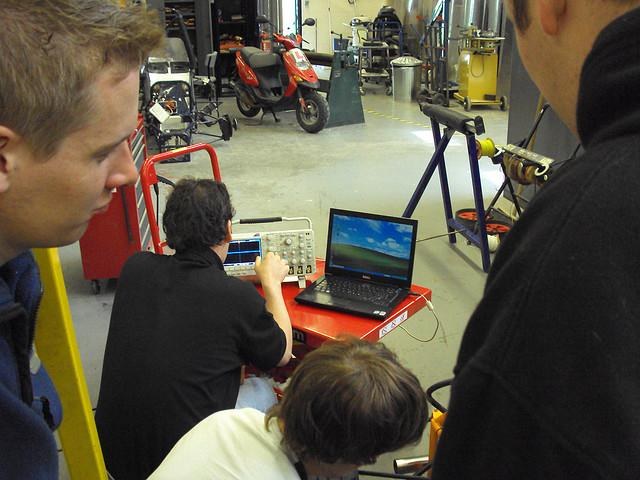What is the man using to control the grey device?

Choices:
A) desktop
B) phone
C) laptop
D) remote laptop 